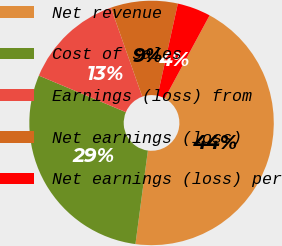<chart> <loc_0><loc_0><loc_500><loc_500><pie_chart><fcel>Net revenue<fcel>Cost of sales<fcel>Earnings (loss) from<fcel>Net earnings (loss)<fcel>Net earnings (loss) per<nl><fcel>44.23%<fcel>29.22%<fcel>13.27%<fcel>8.85%<fcel>4.42%<nl></chart> 